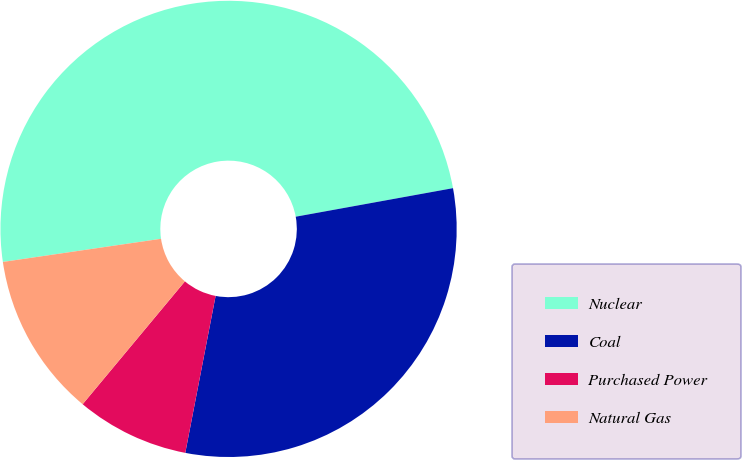Convert chart to OTSL. <chart><loc_0><loc_0><loc_500><loc_500><pie_chart><fcel>Nuclear<fcel>Coal<fcel>Purchased Power<fcel>Natural Gas<nl><fcel>49.46%<fcel>30.9%<fcel>8.01%<fcel>11.64%<nl></chart> 